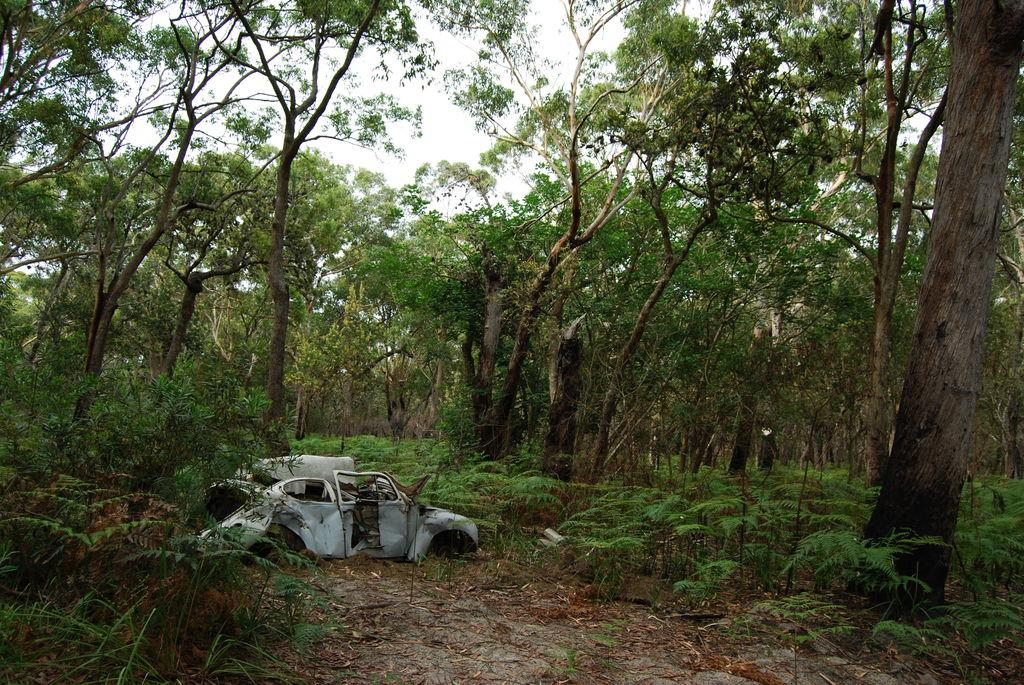What is the condition of the car in the image? The car in the image is damaged and on the ground. What type of vegetation can be seen in the image? There are plants, shrubs, and trees present in the image. What is the condition of the leaves in the image? The leaves in the image are shredded. What part of the natural environment is visible in the image? The sky is visible in the image. Can you describe the person holding the clam in the drawer in the image? There is no person, clam, or drawer present in the image. 